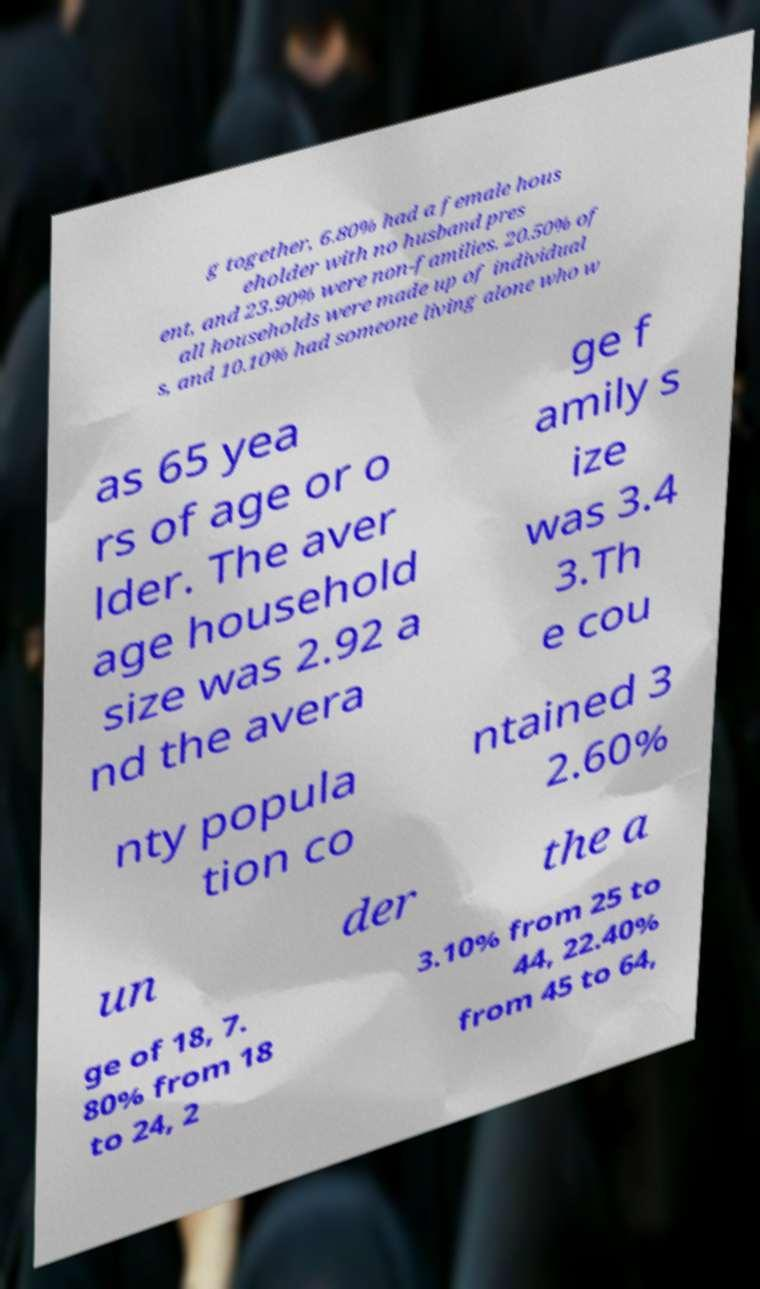For documentation purposes, I need the text within this image transcribed. Could you provide that? g together, 6.80% had a female hous eholder with no husband pres ent, and 23.90% were non-families. 20.50% of all households were made up of individual s, and 10.10% had someone living alone who w as 65 yea rs of age or o lder. The aver age household size was 2.92 a nd the avera ge f amily s ize was 3.4 3.Th e cou nty popula tion co ntained 3 2.60% un der the a ge of 18, 7. 80% from 18 to 24, 2 3.10% from 25 to 44, 22.40% from 45 to 64, 